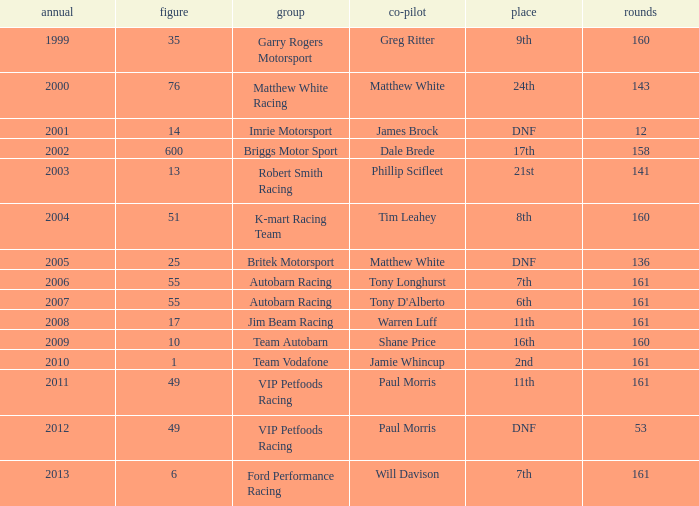What is the fewest laps for a team with a position of DNF and a number smaller than 25 before 2001? None. 